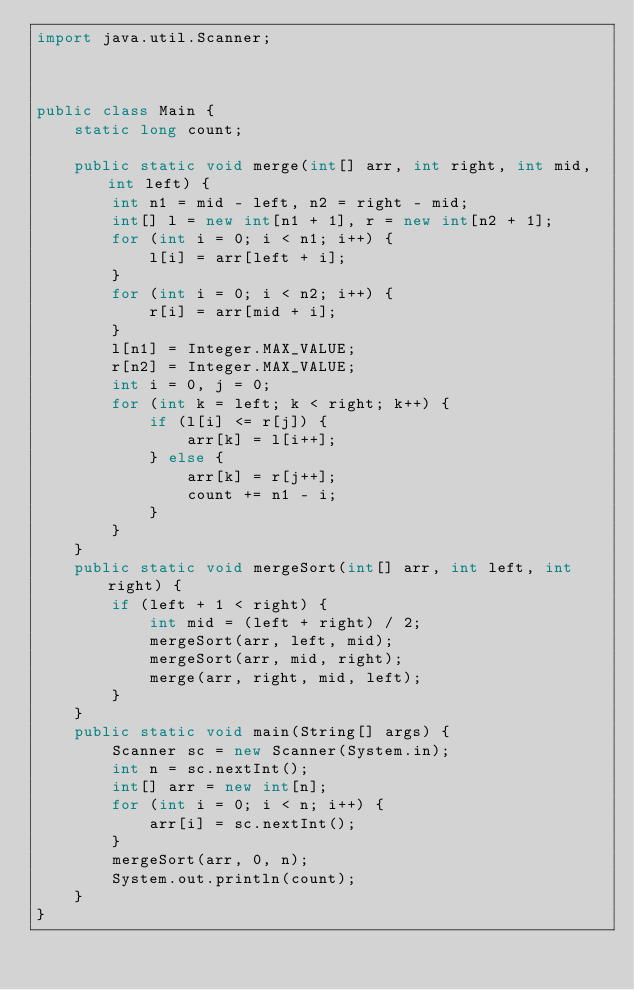<code> <loc_0><loc_0><loc_500><loc_500><_Java_>import java.util.Scanner;



public class Main {
	static long count;

	public static void merge(int[] arr, int right, int mid, int left) {
		int n1 = mid - left, n2 = right - mid;
		int[] l = new int[n1 + 1], r = new int[n2 + 1];
		for (int i = 0; i < n1; i++) {
			l[i] = arr[left + i];
		}
		for (int i = 0; i < n2; i++) {
			r[i] = arr[mid + i];
		}
		l[n1] = Integer.MAX_VALUE;
		r[n2] = Integer.MAX_VALUE;
		int i = 0, j = 0;
		for (int k = left; k < right; k++) {
			if (l[i] <= r[j]) {
				arr[k] = l[i++];
			} else {
				arr[k] = r[j++];
				count += n1 - i;
			}
		}
	}
	public static void mergeSort(int[] arr, int left, int right) {
		if (left + 1 < right) {
			int mid = (left + right) / 2;
			mergeSort(arr, left, mid);
			mergeSort(arr, mid, right);
			merge(arr, right, mid, left);
		}
	}
	public static void main(String[] args) {
		Scanner sc = new Scanner(System.in);
		int n = sc.nextInt();
		int[] arr = new int[n];
		for (int i = 0; i < n; i++) {
			arr[i] = sc.nextInt();
		}
		mergeSort(arr, 0, n);
		System.out.println(count);
	}
}
</code> 